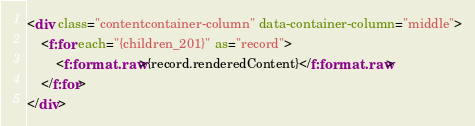<code> <loc_0><loc_0><loc_500><loc_500><_HTML_><div class="contentcontainer-column" data-container-column="middle">
    <f:for each="{children_201}" as="record">
        <f:format.raw>{record.renderedContent}</f:format.raw>
    </f:for>
</div>


</code> 